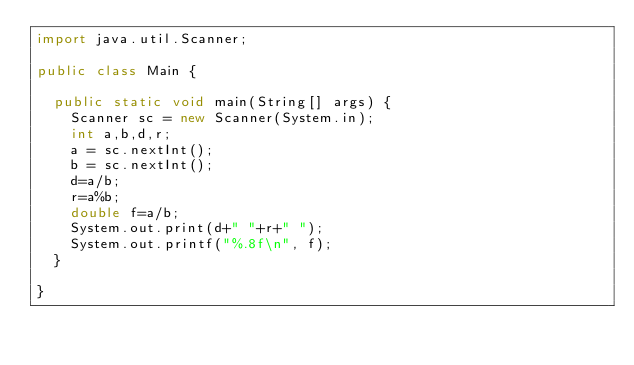Convert code to text. <code><loc_0><loc_0><loc_500><loc_500><_Java_>import java.util.Scanner;

public class Main {

	public static void main(String[] args) {
		Scanner sc = new Scanner(System.in);
		int a,b,d,r;
		a = sc.nextInt();
		b = sc.nextInt();
		d=a/b;
		r=a%b;
		double f=a/b;
		System.out.print(d+" "+r+" ");
		System.out.printf("%.8f\n", f);
	}

}</code> 